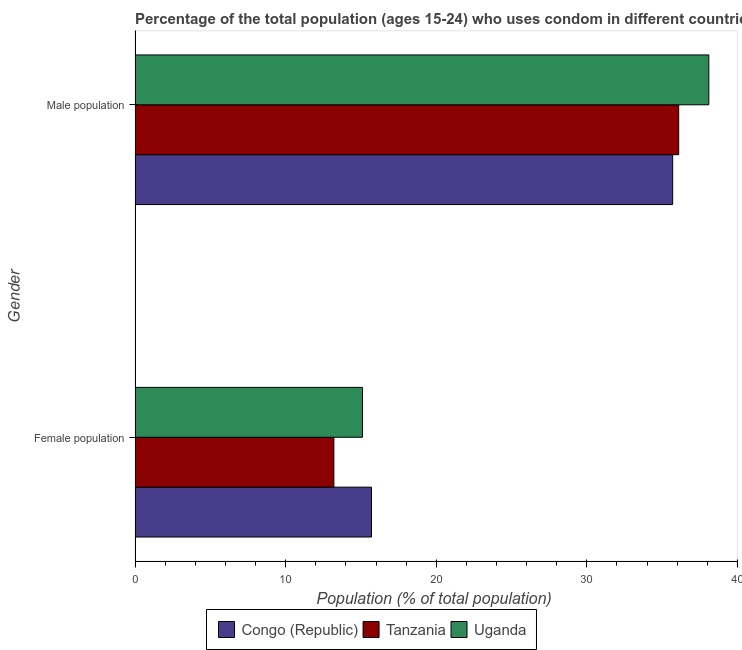How many groups of bars are there?
Your answer should be compact. 2. How many bars are there on the 2nd tick from the bottom?
Offer a terse response. 3. What is the label of the 1st group of bars from the top?
Offer a very short reply. Male population. Across all countries, what is the maximum male population?
Your answer should be very brief. 38.1. Across all countries, what is the minimum male population?
Give a very brief answer. 35.7. In which country was the male population maximum?
Keep it short and to the point. Uganda. In which country was the male population minimum?
Offer a very short reply. Congo (Republic). What is the total male population in the graph?
Provide a succinct answer. 109.9. What is the difference between the female population in Uganda and that in Congo (Republic)?
Ensure brevity in your answer.  -0.6. What is the difference between the male population in Uganda and the female population in Tanzania?
Your response must be concise. 24.9. What is the average male population per country?
Make the answer very short. 36.63. What is the difference between the female population and male population in Tanzania?
Offer a very short reply. -22.9. In how many countries, is the female population greater than 24 %?
Provide a short and direct response. 0. What is the ratio of the female population in Congo (Republic) to that in Uganda?
Your response must be concise. 1.04. In how many countries, is the male population greater than the average male population taken over all countries?
Ensure brevity in your answer.  1. What does the 1st bar from the top in Female population represents?
Keep it short and to the point. Uganda. What does the 1st bar from the bottom in Female population represents?
Your response must be concise. Congo (Republic). How many bars are there?
Offer a terse response. 6. Does the graph contain grids?
Your response must be concise. No. How many legend labels are there?
Provide a succinct answer. 3. How are the legend labels stacked?
Offer a very short reply. Horizontal. What is the title of the graph?
Provide a short and direct response. Percentage of the total population (ages 15-24) who uses condom in different countries. What is the label or title of the X-axis?
Ensure brevity in your answer.  Population (% of total population) . What is the label or title of the Y-axis?
Provide a succinct answer. Gender. What is the Population (% of total population)  of Congo (Republic) in Female population?
Your answer should be very brief. 15.7. What is the Population (% of total population)  of Congo (Republic) in Male population?
Offer a terse response. 35.7. What is the Population (% of total population)  of Tanzania in Male population?
Ensure brevity in your answer.  36.1. What is the Population (% of total population)  of Uganda in Male population?
Your response must be concise. 38.1. Across all Gender, what is the maximum Population (% of total population)  of Congo (Republic)?
Your response must be concise. 35.7. Across all Gender, what is the maximum Population (% of total population)  in Tanzania?
Keep it short and to the point. 36.1. Across all Gender, what is the maximum Population (% of total population)  of Uganda?
Provide a succinct answer. 38.1. Across all Gender, what is the minimum Population (% of total population)  in Congo (Republic)?
Provide a succinct answer. 15.7. Across all Gender, what is the minimum Population (% of total population)  in Uganda?
Ensure brevity in your answer.  15.1. What is the total Population (% of total population)  in Congo (Republic) in the graph?
Provide a short and direct response. 51.4. What is the total Population (% of total population)  of Tanzania in the graph?
Your answer should be very brief. 49.3. What is the total Population (% of total population)  in Uganda in the graph?
Ensure brevity in your answer.  53.2. What is the difference between the Population (% of total population)  of Congo (Republic) in Female population and that in Male population?
Provide a succinct answer. -20. What is the difference between the Population (% of total population)  of Tanzania in Female population and that in Male population?
Your response must be concise. -22.9. What is the difference between the Population (% of total population)  in Congo (Republic) in Female population and the Population (% of total population)  in Tanzania in Male population?
Keep it short and to the point. -20.4. What is the difference between the Population (% of total population)  of Congo (Republic) in Female population and the Population (% of total population)  of Uganda in Male population?
Offer a terse response. -22.4. What is the difference between the Population (% of total population)  in Tanzania in Female population and the Population (% of total population)  in Uganda in Male population?
Offer a very short reply. -24.9. What is the average Population (% of total population)  in Congo (Republic) per Gender?
Your response must be concise. 25.7. What is the average Population (% of total population)  of Tanzania per Gender?
Offer a very short reply. 24.65. What is the average Population (% of total population)  in Uganda per Gender?
Give a very brief answer. 26.6. What is the difference between the Population (% of total population)  of Congo (Republic) and Population (% of total population)  of Uganda in Female population?
Offer a very short reply. 0.6. What is the difference between the Population (% of total population)  of Congo (Republic) and Population (% of total population)  of Tanzania in Male population?
Your response must be concise. -0.4. What is the difference between the Population (% of total population)  of Congo (Republic) and Population (% of total population)  of Uganda in Male population?
Provide a succinct answer. -2.4. What is the ratio of the Population (% of total population)  of Congo (Republic) in Female population to that in Male population?
Your response must be concise. 0.44. What is the ratio of the Population (% of total population)  in Tanzania in Female population to that in Male population?
Offer a very short reply. 0.37. What is the ratio of the Population (% of total population)  in Uganda in Female population to that in Male population?
Your response must be concise. 0.4. What is the difference between the highest and the second highest Population (% of total population)  of Tanzania?
Your answer should be very brief. 22.9. What is the difference between the highest and the second highest Population (% of total population)  in Uganda?
Provide a succinct answer. 23. What is the difference between the highest and the lowest Population (% of total population)  in Congo (Republic)?
Provide a short and direct response. 20. What is the difference between the highest and the lowest Population (% of total population)  in Tanzania?
Make the answer very short. 22.9. 